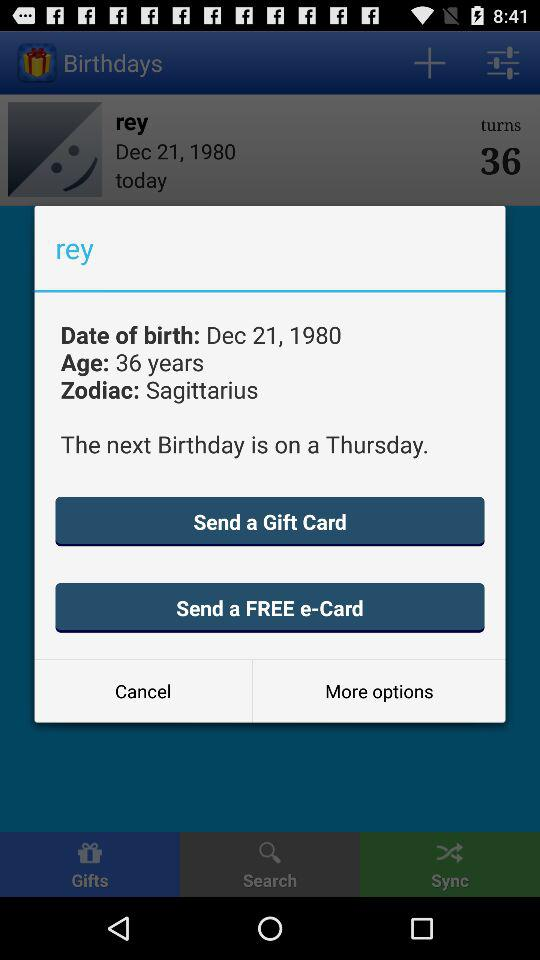Are there any gifts?
When the provided information is insufficient, respond with <no answer>. <no answer> 